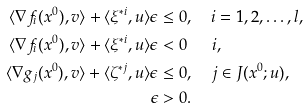Convert formula to latex. <formula><loc_0><loc_0><loc_500><loc_500>\langle \nabla f _ { i } ( x ^ { 0 } ) , v \rangle + \langle \xi ^ { * i } , u \rangle \epsilon & \leq 0 , \quad i = 1 , 2 , \dots , l , \\ \langle \nabla f _ { i } ( x ^ { 0 } ) , v \rangle + \langle \xi ^ { * i } , u \rangle \epsilon & < 0 \quad \ \ i , \\ \langle \nabla g _ { j } ( x ^ { 0 } ) , v \rangle + \langle \zeta ^ { * j } , u \rangle \epsilon & \leq 0 , \quad j \in J ( x ^ { 0 } ; u ) , \\ \epsilon & > 0 .</formula> 